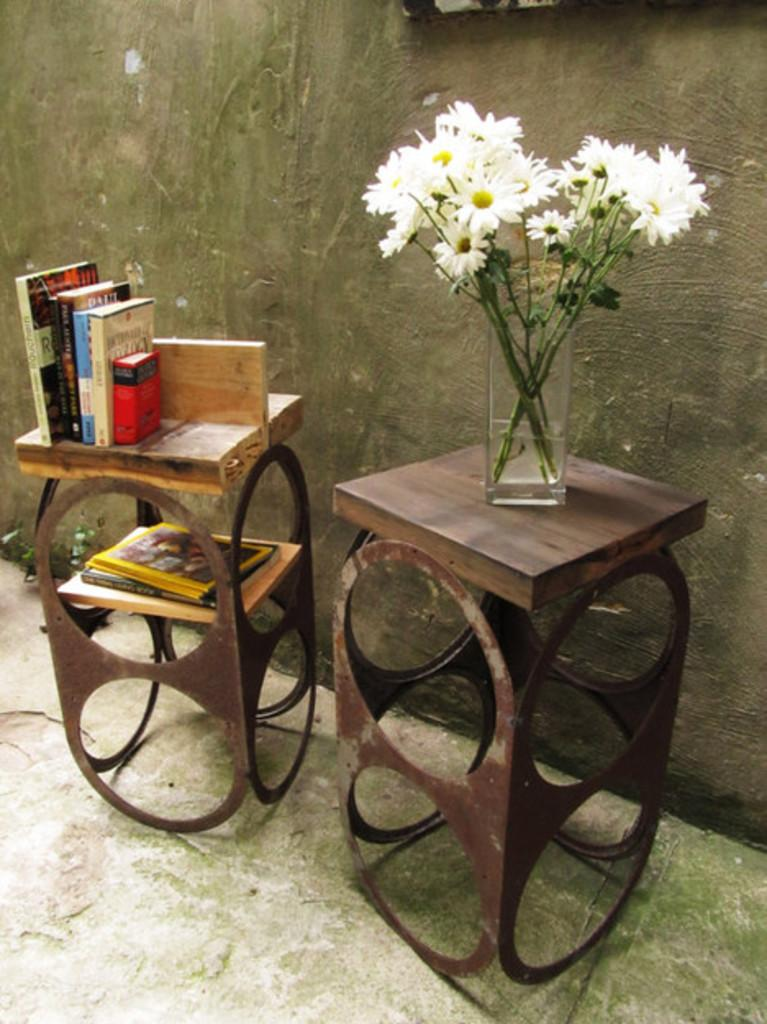How many stands can be seen in the image? There are two stands in the image. What is on the table with the jar of flowers? There is a jar with flowers on one table. What is on the other table? There are books on the other table. What can be seen in the background of the image? The wall is visible in the image. Where is the bomb located in the image? There is no bomb present in the image. What type of oven can be seen in the image? There is no oven present in the image. 